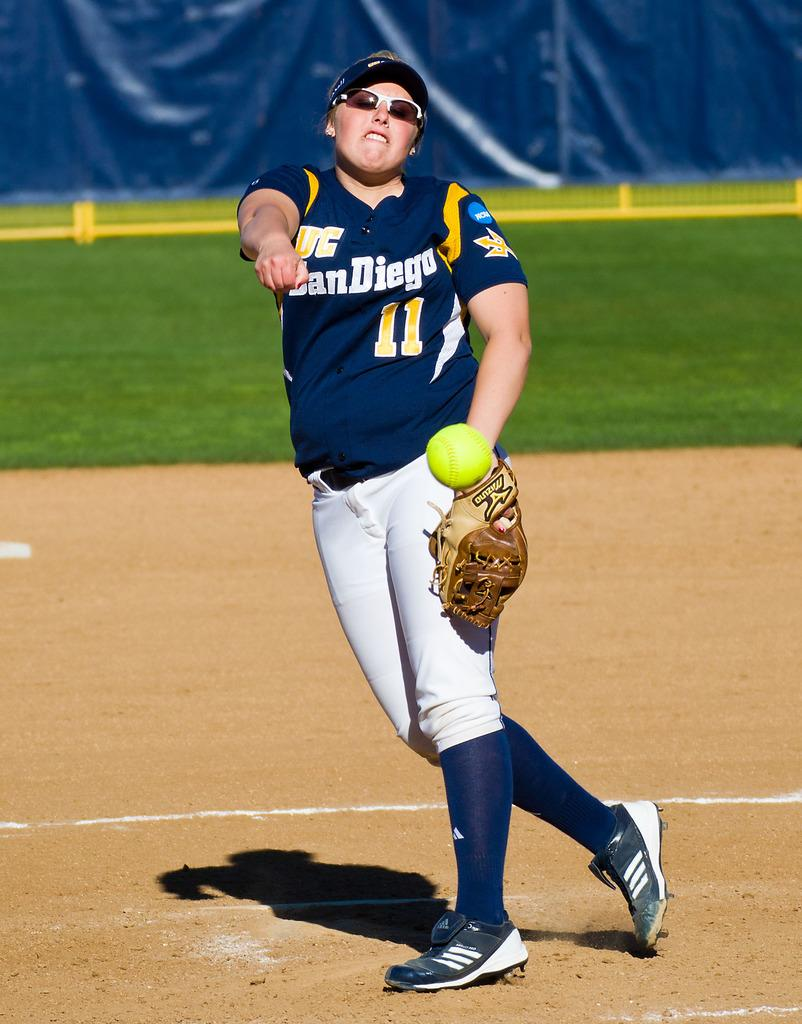<image>
Create a compact narrative representing the image presented. the softball player wearing number 11 jersey is throwing the ball 